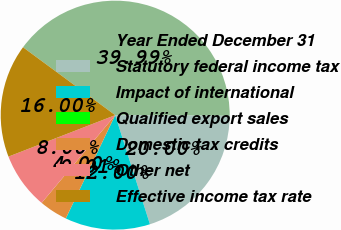<chart> <loc_0><loc_0><loc_500><loc_500><pie_chart><fcel>Year Ended December 31<fcel>Statutory federal income tax<fcel>Impact of international<fcel>Qualified export sales<fcel>Domestic tax credits<fcel>Other net<fcel>Effective income tax rate<nl><fcel>39.99%<fcel>20.0%<fcel>12.0%<fcel>0.01%<fcel>4.0%<fcel>8.0%<fcel>16.0%<nl></chart> 